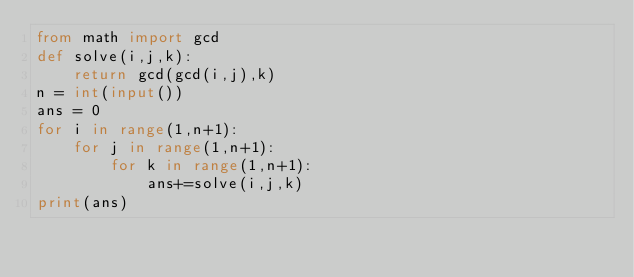<code> <loc_0><loc_0><loc_500><loc_500><_Python_>from math import gcd
def solve(i,j,k):
    return gcd(gcd(i,j),k)
n = int(input())
ans = 0
for i in range(1,n+1):
    for j in range(1,n+1):
        for k in range(1,n+1):
            ans+=solve(i,j,k)
print(ans)</code> 